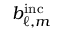<formula> <loc_0><loc_0><loc_500><loc_500>b _ { \ell , m } ^ { i n c }</formula> 